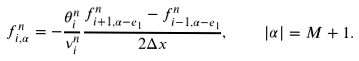Convert formula to latex. <formula><loc_0><loc_0><loc_500><loc_500>f _ { i , \alpha } ^ { n } = - \frac { \theta _ { i } ^ { n } } { \nu _ { i } ^ { n } } \frac { f _ { i + 1 , \alpha - e _ { 1 } } ^ { n } - f _ { i - 1 , \alpha - e _ { 1 } } ^ { n } } { 2 \Delta x } , \quad | \alpha | = M + 1 .</formula> 